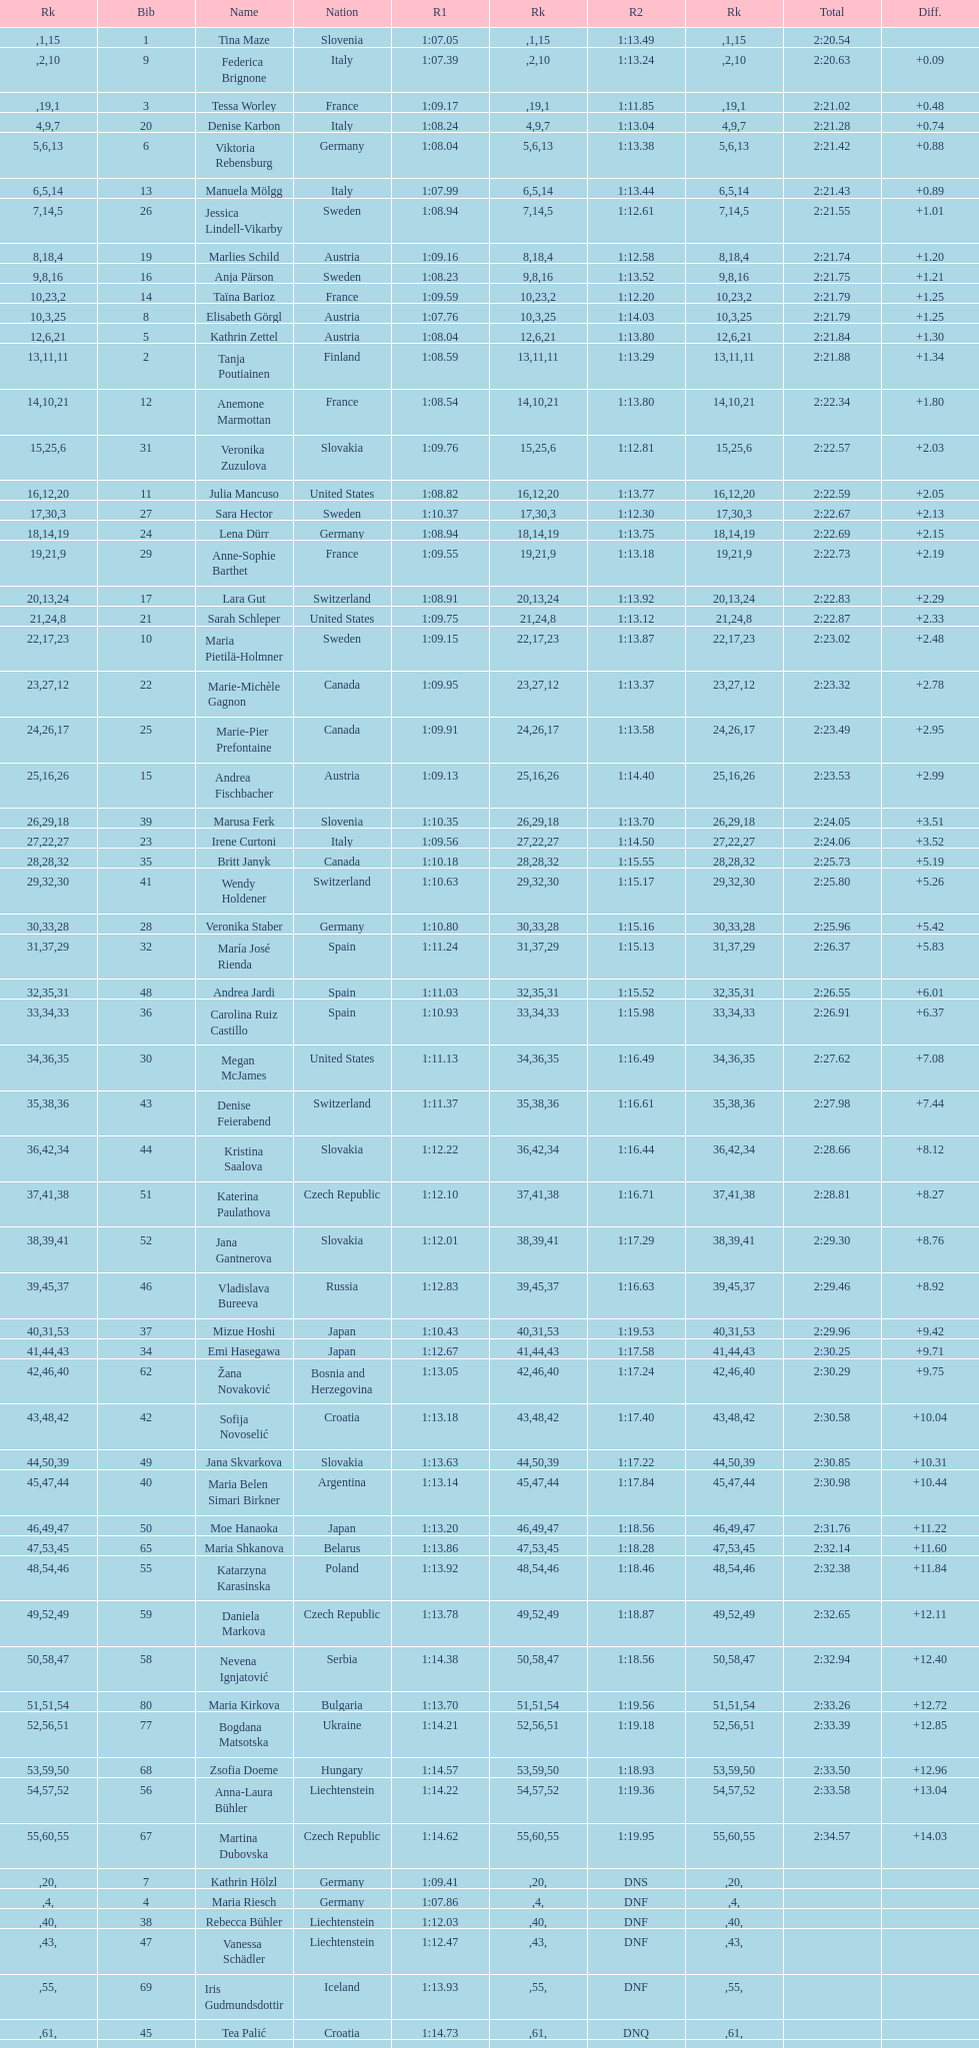Can you give me this table as a dict? {'header': ['Rk', 'Bib', 'Name', 'Nation', 'R1', 'Rk', 'R2', 'Rk', 'Total', 'Diff.'], 'rows': [['', '1', 'Tina Maze', 'Slovenia', '1:07.05', '1', '1:13.49', '15', '2:20.54', ''], ['', '9', 'Federica Brignone', 'Italy', '1:07.39', '2', '1:13.24', '10', '2:20.63', '+0.09'], ['', '3', 'Tessa Worley', 'France', '1:09.17', '19', '1:11.85', '1', '2:21.02', '+0.48'], ['4', '20', 'Denise Karbon', 'Italy', '1:08.24', '9', '1:13.04', '7', '2:21.28', '+0.74'], ['5', '6', 'Viktoria Rebensburg', 'Germany', '1:08.04', '6', '1:13.38', '13', '2:21.42', '+0.88'], ['6', '13', 'Manuela Mölgg', 'Italy', '1:07.99', '5', '1:13.44', '14', '2:21.43', '+0.89'], ['7', '26', 'Jessica Lindell-Vikarby', 'Sweden', '1:08.94', '14', '1:12.61', '5', '2:21.55', '+1.01'], ['8', '19', 'Marlies Schild', 'Austria', '1:09.16', '18', '1:12.58', '4', '2:21.74', '+1.20'], ['9', '16', 'Anja Pärson', 'Sweden', '1:08.23', '8', '1:13.52', '16', '2:21.75', '+1.21'], ['10', '14', 'Taïna Barioz', 'France', '1:09.59', '23', '1:12.20', '2', '2:21.79', '+1.25'], ['10', '8', 'Elisabeth Görgl', 'Austria', '1:07.76', '3', '1:14.03', '25', '2:21.79', '+1.25'], ['12', '5', 'Kathrin Zettel', 'Austria', '1:08.04', '6', '1:13.80', '21', '2:21.84', '+1.30'], ['13', '2', 'Tanja Poutiainen', 'Finland', '1:08.59', '11', '1:13.29', '11', '2:21.88', '+1.34'], ['14', '12', 'Anemone Marmottan', 'France', '1:08.54', '10', '1:13.80', '21', '2:22.34', '+1.80'], ['15', '31', 'Veronika Zuzulova', 'Slovakia', '1:09.76', '25', '1:12.81', '6', '2:22.57', '+2.03'], ['16', '11', 'Julia Mancuso', 'United States', '1:08.82', '12', '1:13.77', '20', '2:22.59', '+2.05'], ['17', '27', 'Sara Hector', 'Sweden', '1:10.37', '30', '1:12.30', '3', '2:22.67', '+2.13'], ['18', '24', 'Lena Dürr', 'Germany', '1:08.94', '14', '1:13.75', '19', '2:22.69', '+2.15'], ['19', '29', 'Anne-Sophie Barthet', 'France', '1:09.55', '21', '1:13.18', '9', '2:22.73', '+2.19'], ['20', '17', 'Lara Gut', 'Switzerland', '1:08.91', '13', '1:13.92', '24', '2:22.83', '+2.29'], ['21', '21', 'Sarah Schleper', 'United States', '1:09.75', '24', '1:13.12', '8', '2:22.87', '+2.33'], ['22', '10', 'Maria Pietilä-Holmner', 'Sweden', '1:09.15', '17', '1:13.87', '23', '2:23.02', '+2.48'], ['23', '22', 'Marie-Michèle Gagnon', 'Canada', '1:09.95', '27', '1:13.37', '12', '2:23.32', '+2.78'], ['24', '25', 'Marie-Pier Prefontaine', 'Canada', '1:09.91', '26', '1:13.58', '17', '2:23.49', '+2.95'], ['25', '15', 'Andrea Fischbacher', 'Austria', '1:09.13', '16', '1:14.40', '26', '2:23.53', '+2.99'], ['26', '39', 'Marusa Ferk', 'Slovenia', '1:10.35', '29', '1:13.70', '18', '2:24.05', '+3.51'], ['27', '23', 'Irene Curtoni', 'Italy', '1:09.56', '22', '1:14.50', '27', '2:24.06', '+3.52'], ['28', '35', 'Britt Janyk', 'Canada', '1:10.18', '28', '1:15.55', '32', '2:25.73', '+5.19'], ['29', '41', 'Wendy Holdener', 'Switzerland', '1:10.63', '32', '1:15.17', '30', '2:25.80', '+5.26'], ['30', '28', 'Veronika Staber', 'Germany', '1:10.80', '33', '1:15.16', '28', '2:25.96', '+5.42'], ['31', '32', 'María José Rienda', 'Spain', '1:11.24', '37', '1:15.13', '29', '2:26.37', '+5.83'], ['32', '48', 'Andrea Jardi', 'Spain', '1:11.03', '35', '1:15.52', '31', '2:26.55', '+6.01'], ['33', '36', 'Carolina Ruiz Castillo', 'Spain', '1:10.93', '34', '1:15.98', '33', '2:26.91', '+6.37'], ['34', '30', 'Megan McJames', 'United States', '1:11.13', '36', '1:16.49', '35', '2:27.62', '+7.08'], ['35', '43', 'Denise Feierabend', 'Switzerland', '1:11.37', '38', '1:16.61', '36', '2:27.98', '+7.44'], ['36', '44', 'Kristina Saalova', 'Slovakia', '1:12.22', '42', '1:16.44', '34', '2:28.66', '+8.12'], ['37', '51', 'Katerina Paulathova', 'Czech Republic', '1:12.10', '41', '1:16.71', '38', '2:28.81', '+8.27'], ['38', '52', 'Jana Gantnerova', 'Slovakia', '1:12.01', '39', '1:17.29', '41', '2:29.30', '+8.76'], ['39', '46', 'Vladislava Bureeva', 'Russia', '1:12.83', '45', '1:16.63', '37', '2:29.46', '+8.92'], ['40', '37', 'Mizue Hoshi', 'Japan', '1:10.43', '31', '1:19.53', '53', '2:29.96', '+9.42'], ['41', '34', 'Emi Hasegawa', 'Japan', '1:12.67', '44', '1:17.58', '43', '2:30.25', '+9.71'], ['42', '62', 'Žana Novaković', 'Bosnia and Herzegovina', '1:13.05', '46', '1:17.24', '40', '2:30.29', '+9.75'], ['43', '42', 'Sofija Novoselić', 'Croatia', '1:13.18', '48', '1:17.40', '42', '2:30.58', '+10.04'], ['44', '49', 'Jana Skvarkova', 'Slovakia', '1:13.63', '50', '1:17.22', '39', '2:30.85', '+10.31'], ['45', '40', 'Maria Belen Simari Birkner', 'Argentina', '1:13.14', '47', '1:17.84', '44', '2:30.98', '+10.44'], ['46', '50', 'Moe Hanaoka', 'Japan', '1:13.20', '49', '1:18.56', '47', '2:31.76', '+11.22'], ['47', '65', 'Maria Shkanova', 'Belarus', '1:13.86', '53', '1:18.28', '45', '2:32.14', '+11.60'], ['48', '55', 'Katarzyna Karasinska', 'Poland', '1:13.92', '54', '1:18.46', '46', '2:32.38', '+11.84'], ['49', '59', 'Daniela Markova', 'Czech Republic', '1:13.78', '52', '1:18.87', '49', '2:32.65', '+12.11'], ['50', '58', 'Nevena Ignjatović', 'Serbia', '1:14.38', '58', '1:18.56', '47', '2:32.94', '+12.40'], ['51', '80', 'Maria Kirkova', 'Bulgaria', '1:13.70', '51', '1:19.56', '54', '2:33.26', '+12.72'], ['52', '77', 'Bogdana Matsotska', 'Ukraine', '1:14.21', '56', '1:19.18', '51', '2:33.39', '+12.85'], ['53', '68', 'Zsofia Doeme', 'Hungary', '1:14.57', '59', '1:18.93', '50', '2:33.50', '+12.96'], ['54', '56', 'Anna-Laura Bühler', 'Liechtenstein', '1:14.22', '57', '1:19.36', '52', '2:33.58', '+13.04'], ['55', '67', 'Martina Dubovska', 'Czech Republic', '1:14.62', '60', '1:19.95', '55', '2:34.57', '+14.03'], ['', '7', 'Kathrin Hölzl', 'Germany', '1:09.41', '20', 'DNS', '', '', ''], ['', '4', 'Maria Riesch', 'Germany', '1:07.86', '4', 'DNF', '', '', ''], ['', '38', 'Rebecca Bühler', 'Liechtenstein', '1:12.03', '40', 'DNF', '', '', ''], ['', '47', 'Vanessa Schädler', 'Liechtenstein', '1:12.47', '43', 'DNF', '', '', ''], ['', '69', 'Iris Gudmundsdottir', 'Iceland', '1:13.93', '55', 'DNF', '', '', ''], ['', '45', 'Tea Palić', 'Croatia', '1:14.73', '61', 'DNQ', '', '', ''], ['', '74', 'Macarena Simari Birkner', 'Argentina', '1:15.18', '62', 'DNQ', '', '', ''], ['', '72', 'Lavinia Chrystal', 'Australia', '1:15.35', '63', 'DNQ', '', '', ''], ['', '81', 'Lelde Gasuna', 'Latvia', '1:15.37', '64', 'DNQ', '', '', ''], ['', '64', 'Aleksandra Klus', 'Poland', '1:15.41', '65', 'DNQ', '', '', ''], ['', '78', 'Nino Tsiklauri', 'Georgia', '1:15.54', '66', 'DNQ', '', '', ''], ['', '66', 'Sarah Jarvis', 'New Zealand', '1:15.94', '67', 'DNQ', '', '', ''], ['', '61', 'Anna Berecz', 'Hungary', '1:15.95', '68', 'DNQ', '', '', ''], ['', '83', 'Sandra-Elena Narea', 'Romania', '1:16.67', '69', 'DNQ', '', '', ''], ['', '85', 'Iulia Petruta Craciun', 'Romania', '1:16.80', '70', 'DNQ', '', '', ''], ['', '82', 'Isabel van Buynder', 'Belgium', '1:17.06', '71', 'DNQ', '', '', ''], ['', '97', 'Liene Fimbauere', 'Latvia', '1:17.83', '72', 'DNQ', '', '', ''], ['', '86', 'Kristina Krone', 'Puerto Rico', '1:17.93', '73', 'DNQ', '', '', ''], ['', '88', 'Nicole Valcareggi', 'Greece', '1:18.19', '74', 'DNQ', '', '', ''], ['', '100', 'Sophie Fjellvang-Sølling', 'Denmark', '1:18.37', '75', 'DNQ', '', '', ''], ['', '95', 'Ornella Oettl Reyes', 'Peru', '1:18.61', '76', 'DNQ', '', '', ''], ['', '73', 'Xia Lina', 'China', '1:19.12', '77', 'DNQ', '', '', ''], ['', '94', 'Kseniya Grigoreva', 'Uzbekistan', '1:19.16', '78', 'DNQ', '', '', ''], ['', '87', 'Tugba Dasdemir', 'Turkey', '1:21.50', '79', 'DNQ', '', '', ''], ['', '92', 'Malene Madsen', 'Denmark', '1:22.25', '80', 'DNQ', '', '', ''], ['', '84', 'Liu Yang', 'China', '1:22.80', '81', 'DNQ', '', '', ''], ['', '91', 'Yom Hirshfeld', 'Israel', '1:22.87', '82', 'DNQ', '', '', ''], ['', '75', 'Salome Bancora', 'Argentina', '1:23.08', '83', 'DNQ', '', '', ''], ['', '93', 'Ronnie Kiek-Gedalyahu', 'Israel', '1:23.38', '84', 'DNQ', '', '', ''], ['', '96', 'Chiara Marano', 'Brazil', '1:24.16', '85', 'DNQ', '', '', ''], ['', '113', 'Anne Libak Nielsen', 'Denmark', '1:25.08', '86', 'DNQ', '', '', ''], ['', '105', 'Donata Hellner', 'Hungary', '1:26.97', '87', 'DNQ', '', '', ''], ['', '102', 'Liu Yu', 'China', '1:27.03', '88', 'DNQ', '', '', ''], ['', '109', 'Lida Zvoznikova', 'Kyrgyzstan', '1:27.17', '89', 'DNQ', '', '', ''], ['', '103', 'Szelina Hellner', 'Hungary', '1:27.27', '90', 'DNQ', '', '', ''], ['', '114', 'Irina Volkova', 'Kyrgyzstan', '1:29.73', '91', 'DNQ', '', '', ''], ['', '106', 'Svetlana Baranova', 'Uzbekistan', '1:30.62', '92', 'DNQ', '', '', ''], ['', '108', 'Tatjana Baranova', 'Uzbekistan', '1:31.81', '93', 'DNQ', '', '', ''], ['', '110', 'Fatemeh Kiadarbandsari', 'Iran', '1:32.16', '94', 'DNQ', '', '', ''], ['', '107', 'Ziba Kalhor', 'Iran', '1:32.64', '95', 'DNQ', '', '', ''], ['', '104', 'Paraskevi Mavridou', 'Greece', '1:32.83', '96', 'DNQ', '', '', ''], ['', '99', 'Marjan Kalhor', 'Iran', '1:34.94', '97', 'DNQ', '', '', ''], ['', '112', 'Mitra Kalhor', 'Iran', '1:37.93', '98', 'DNQ', '', '', ''], ['', '115', 'Laura Bauer', 'South Africa', '1:42.19', '99', 'DNQ', '', '', ''], ['', '111', 'Sarah Ekmekejian', 'Lebanon', '1:42.22', '100', 'DNQ', '', '', ''], ['', '18', 'Fabienne Suter', 'Switzerland', 'DNS', '', '', '', '', ''], ['', '98', 'Maja Klepić', 'Bosnia and Herzegovina', 'DNS', '', '', '', '', ''], ['', '33', 'Agniezska Gasienica Daniel', 'Poland', 'DNF', '', '', '', '', ''], ['', '53', 'Karolina Chrapek', 'Poland', 'DNF', '', '', '', '', ''], ['', '54', 'Mireia Gutierrez', 'Andorra', 'DNF', '', '', '', '', ''], ['', '57', 'Brittany Phelan', 'Canada', 'DNF', '', '', '', '', ''], ['', '60', 'Tereza Kmochova', 'Czech Republic', 'DNF', '', '', '', '', ''], ['', '63', 'Michelle van Herwerden', 'Netherlands', 'DNF', '', '', '', '', ''], ['', '70', 'Maya Harrisson', 'Brazil', 'DNF', '', '', '', '', ''], ['', '71', 'Elizabeth Pilat', 'Australia', 'DNF', '', '', '', '', ''], ['', '76', 'Katrin Kristjansdottir', 'Iceland', 'DNF', '', '', '', '', ''], ['', '79', 'Julietta Quiroga', 'Argentina', 'DNF', '', '', '', '', ''], ['', '89', 'Evija Benhena', 'Latvia', 'DNF', '', '', '', '', ''], ['', '90', 'Qin Xiyue', 'China', 'DNF', '', '', '', '', ''], ['', '101', 'Sophia Ralli', 'Greece', 'DNF', '', '', '', '', ''], ['', '116', 'Siranush Maghakyan', 'Armenia', 'DNF', '', '', '', '', '']]} Who was the last competitor to actually finish both runs? Martina Dubovska. 